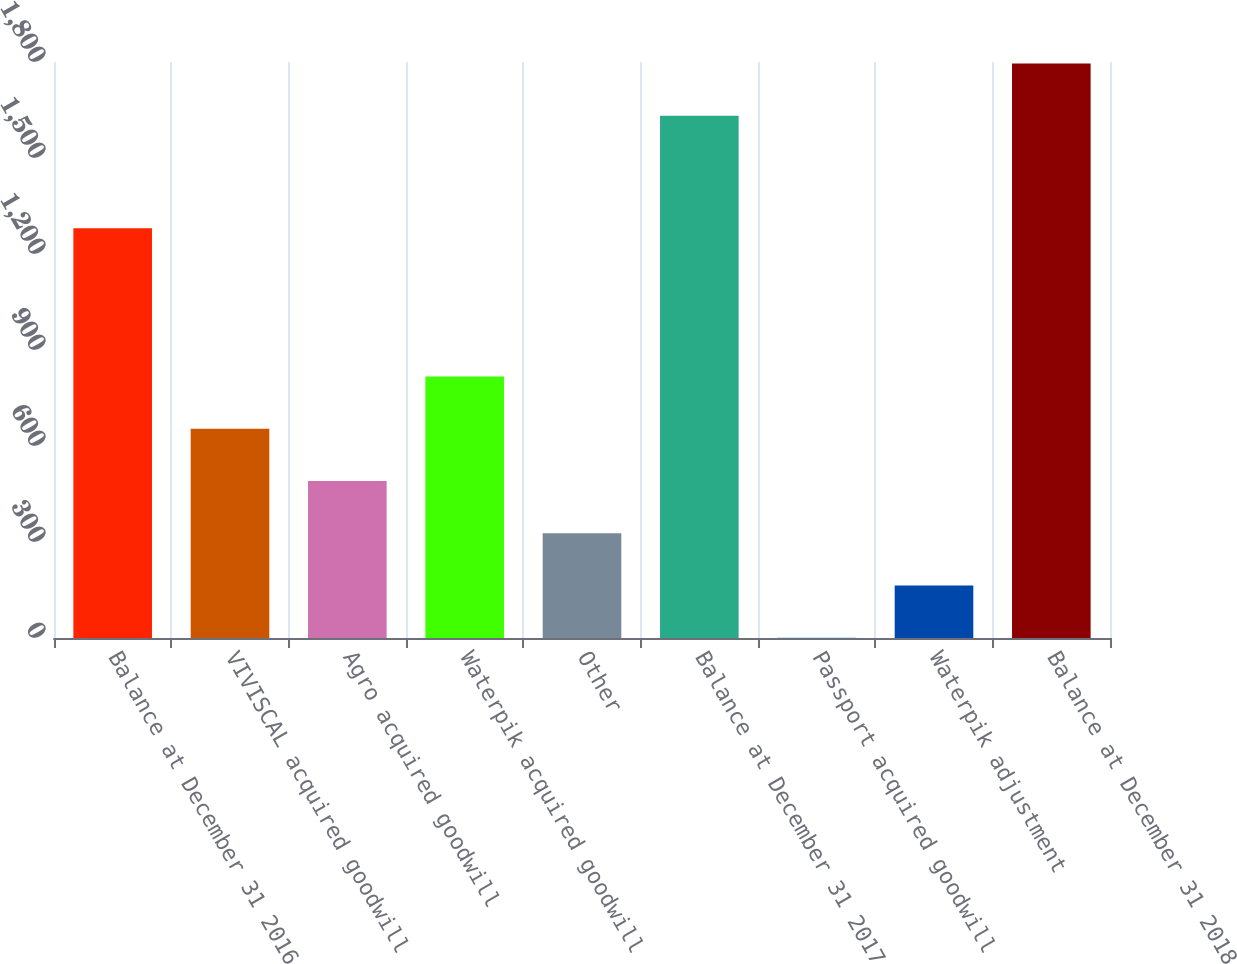<chart> <loc_0><loc_0><loc_500><loc_500><bar_chart><fcel>Balance at December 31 2016<fcel>VIVISCAL acquired goodwill<fcel>Agro acquired goodwill<fcel>Waterpik acquired goodwill<fcel>Other<fcel>Balance at December 31 2017<fcel>Passport acquired goodwill<fcel>Waterpik adjustment<fcel>Balance at December 31 2018<nl><fcel>1280.1<fcel>653.85<fcel>490.62<fcel>817.08<fcel>327.39<fcel>1632.1<fcel>0.93<fcel>164.16<fcel>1795.33<nl></chart> 